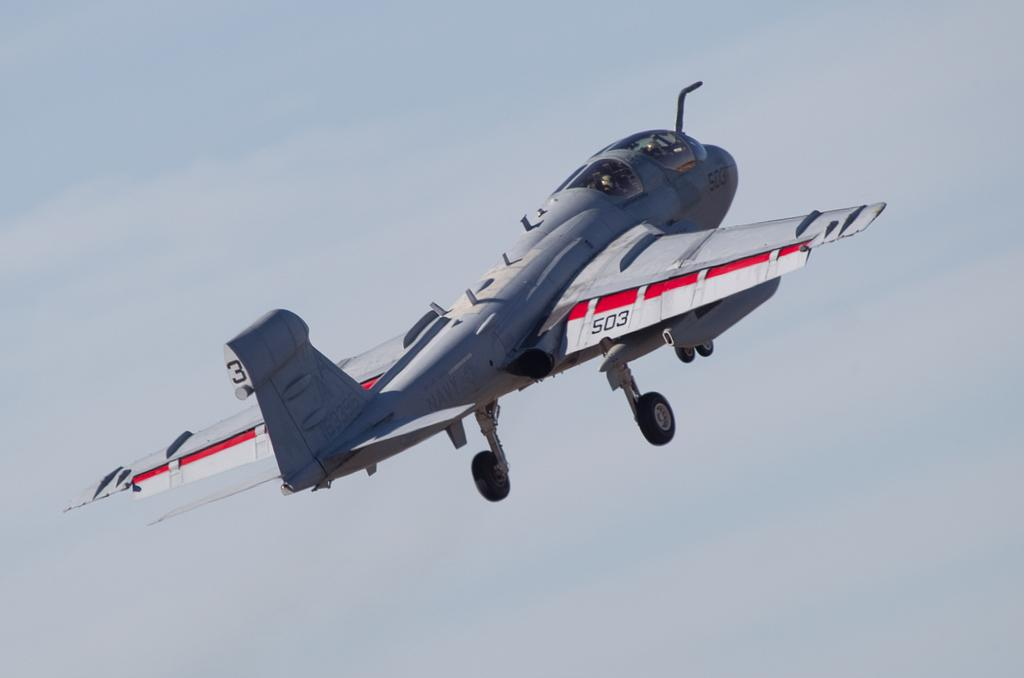What is the main subject of the image? The main subject of the image is an airplane. Where is the airplane located in the image? The airplane is in the sky. Can you see a flock of steam coming from the airplane in the image? There is no steam present in the image, and the airplane is not depicted as producing any steam. 